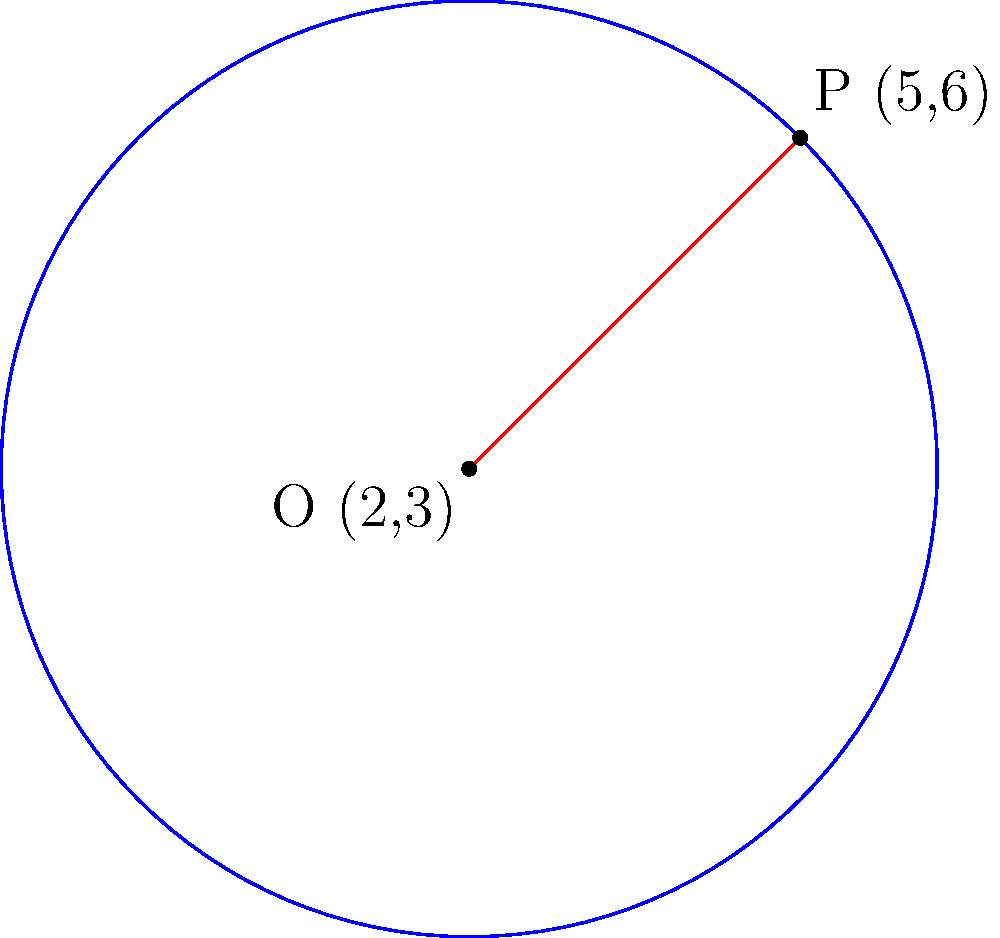Mollie, remember when we used to solve geometry problems together? Here's one that reminds me of those days. Given a circle with center O at (2,3) and a point P (5,6) on its circumference, what is the equation of this circle? Let's approach this step-by-step, Mollie:

1) The general equation of a circle is $$(x-h)^2 + (y-k)^2 = r^2$$
   where (h,k) is the center and r is the radius.

2) We know the center O is at (2,3), so h=2 and k=3.

3) To find the radius, we can calculate the distance between O and P:
   $$r = \sqrt{(x_P-x_O)^2 + (y_P-y_O)^2}$$
   $$r = \sqrt{(5-2)^2 + (6-3)^2} = \sqrt{3^2 + 3^2} = \sqrt{18}$$

4) Now we can substitute these values into the general equation:
   $$(x-2)^2 + (y-3)^2 = (\sqrt{18})^2$$

5) Simplify:
   $$(x-2)^2 + (y-3)^2 = 18$$

This is the equation of the circle.
Answer: $(x-2)^2 + (y-3)^2 = 18$ 